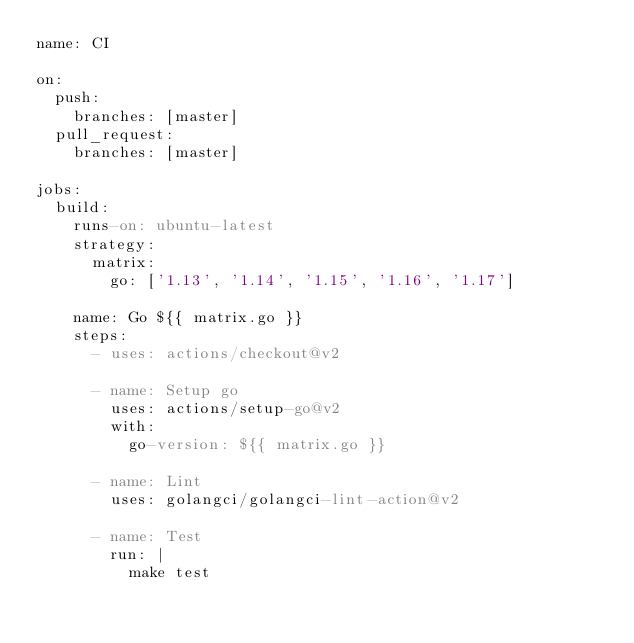<code> <loc_0><loc_0><loc_500><loc_500><_YAML_>name: CI

on:
  push:
    branches: [master]
  pull_request:
    branches: [master]

jobs:
  build:
    runs-on: ubuntu-latest
    strategy:
      matrix:
        go: ['1.13', '1.14', '1.15', '1.16', '1.17']

    name: Go ${{ matrix.go }}
    steps:
      - uses: actions/checkout@v2

      - name: Setup go
        uses: actions/setup-go@v2
        with:
          go-version: ${{ matrix.go }}

      - name: Lint
        uses: golangci/golangci-lint-action@v2

      - name: Test
        run: |
          make test
</code> 